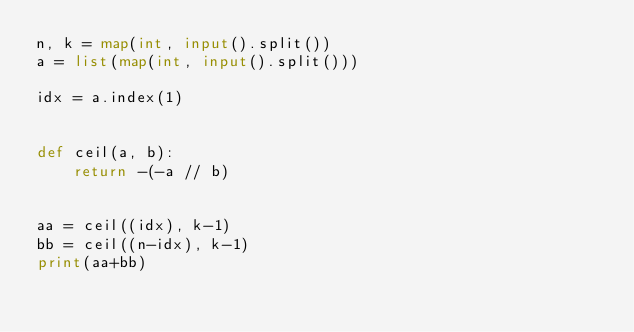<code> <loc_0><loc_0><loc_500><loc_500><_Python_>n, k = map(int, input().split())
a = list(map(int, input().split()))

idx = a.index(1)


def ceil(a, b):
    return -(-a // b)


aa = ceil((idx), k-1)
bb = ceil((n-idx), k-1)
print(aa+bb)
</code> 